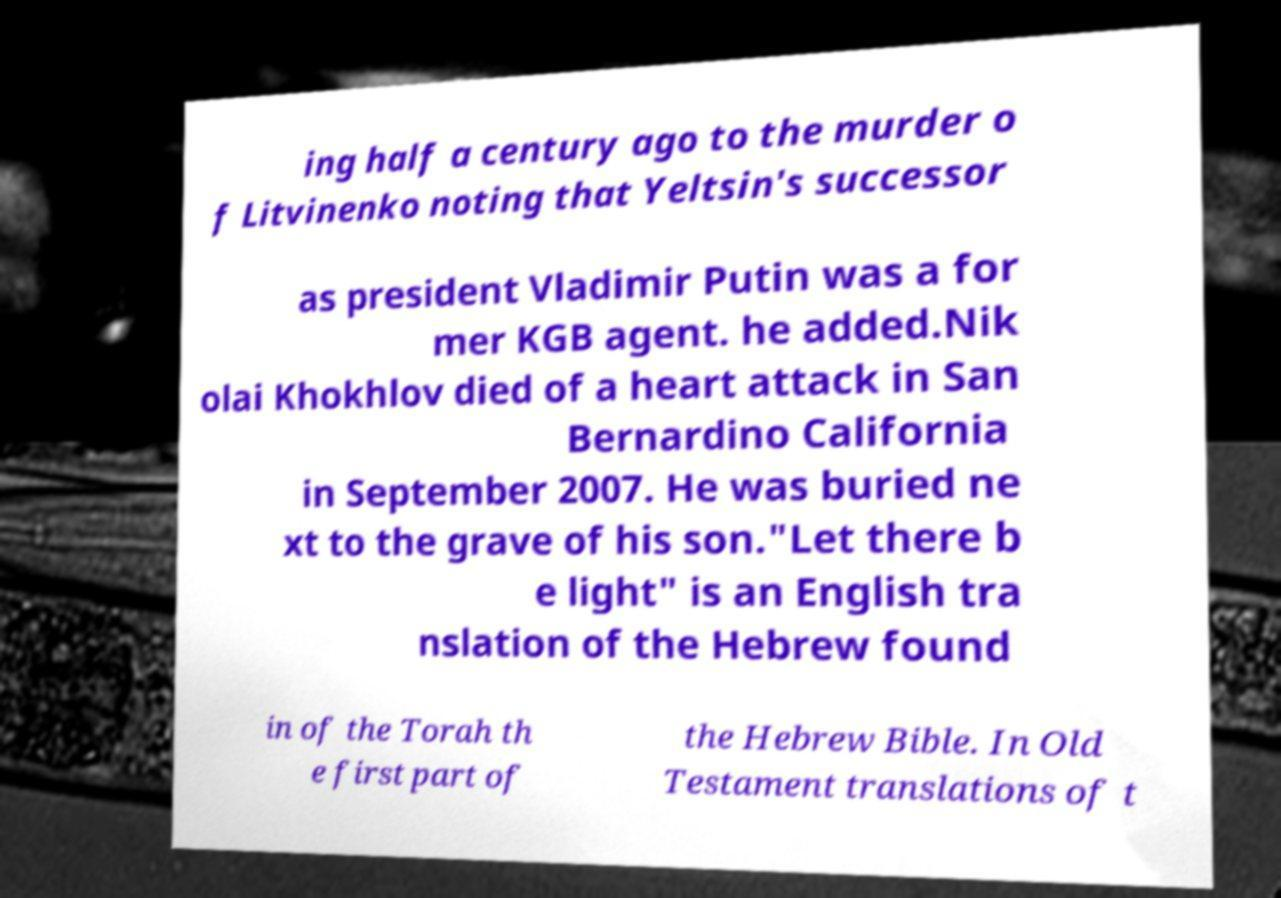I need the written content from this picture converted into text. Can you do that? ing half a century ago to the murder o f Litvinenko noting that Yeltsin's successor as president Vladimir Putin was a for mer KGB agent. he added.Nik olai Khokhlov died of a heart attack in San Bernardino California in September 2007. He was buried ne xt to the grave of his son."Let there b e light" is an English tra nslation of the Hebrew found in of the Torah th e first part of the Hebrew Bible. In Old Testament translations of t 